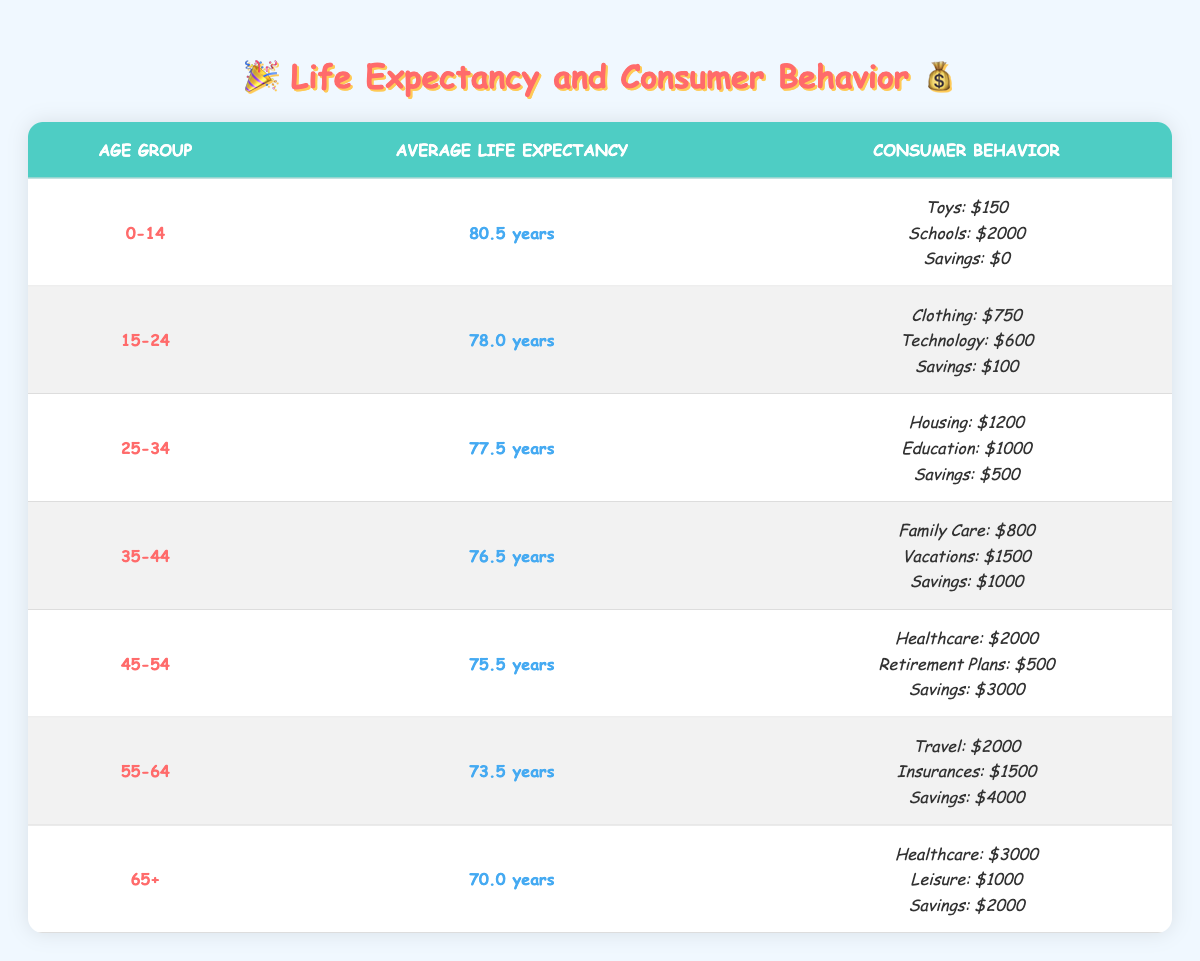What is the average life expectancy for the age group 25-34? The life expectancy for the age group 25-34 is listed in the table as 77.5 years.
Answer: 77.5 years How much do people aged 35-44 spend on family care? Referring to the table, individuals aged 35-44 spend $800 on family care.
Answer: $800 What is the total spending on technology and clothing for the age group 15-24? The age group 15-24 spends $600 on technology and $750 on clothing. Adding these amounts gives $600 + $750 = $1350.
Answer: $1350 Is the average life expectancy for the age group 65+ greater than that of 55-64? The average life expectancy for 65+ is 70.0 years, and for 55-64 it's 73.5 years. Since 70.0 is less than 73.5, the statement is false.
Answer: No Which age group has the highest spending on healthcare? The 65+ age group has the highest spending on healthcare at $3000, as indicated in their consumer behavior section in the table.
Answer: 65+ What is the average spending on education and housing for the age group 25-34? The age group 25-34 spends $1000 on education and $1200 on housing. The average is calculated by taking the sum ($1000 + $1200 = $2200) and dividing by 2, giving $2200 / 2 = $1100.
Answer: $1100 How much personal savings do individuals aged 45-54 have compared to those aged 55-64? Individuals aged 45-54 have $3000 in personal savings, while those aged 55-64 have $4000. Since $3000 is less than $4000, individuals aged 45-54 have less savings.
Answer: Less savings What is the combined spending on leisure and travel for the age group 65+? The 65+ age group spends $1000 on leisure. The travel spending is not applicable for this age group, so the combined spending is just $1000 from leisure.
Answer: $1000 